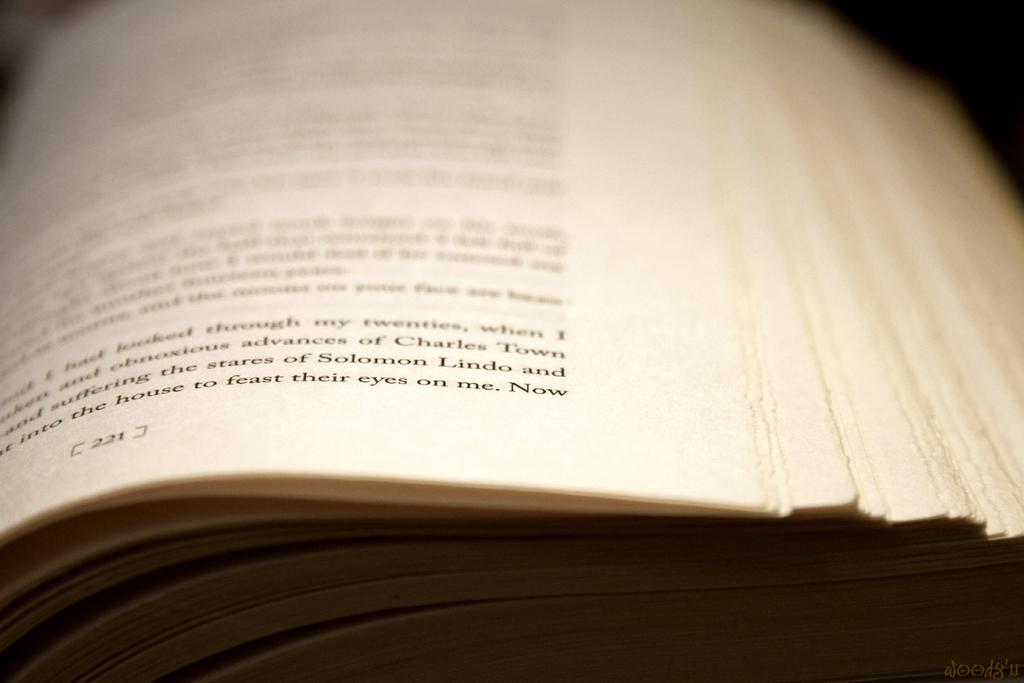What is the page number?
Your answer should be compact. 221. 